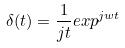Convert formula to latex. <formula><loc_0><loc_0><loc_500><loc_500>\delta ( t ) = \frac { 1 } { j t } e x p ^ { j w t }</formula> 